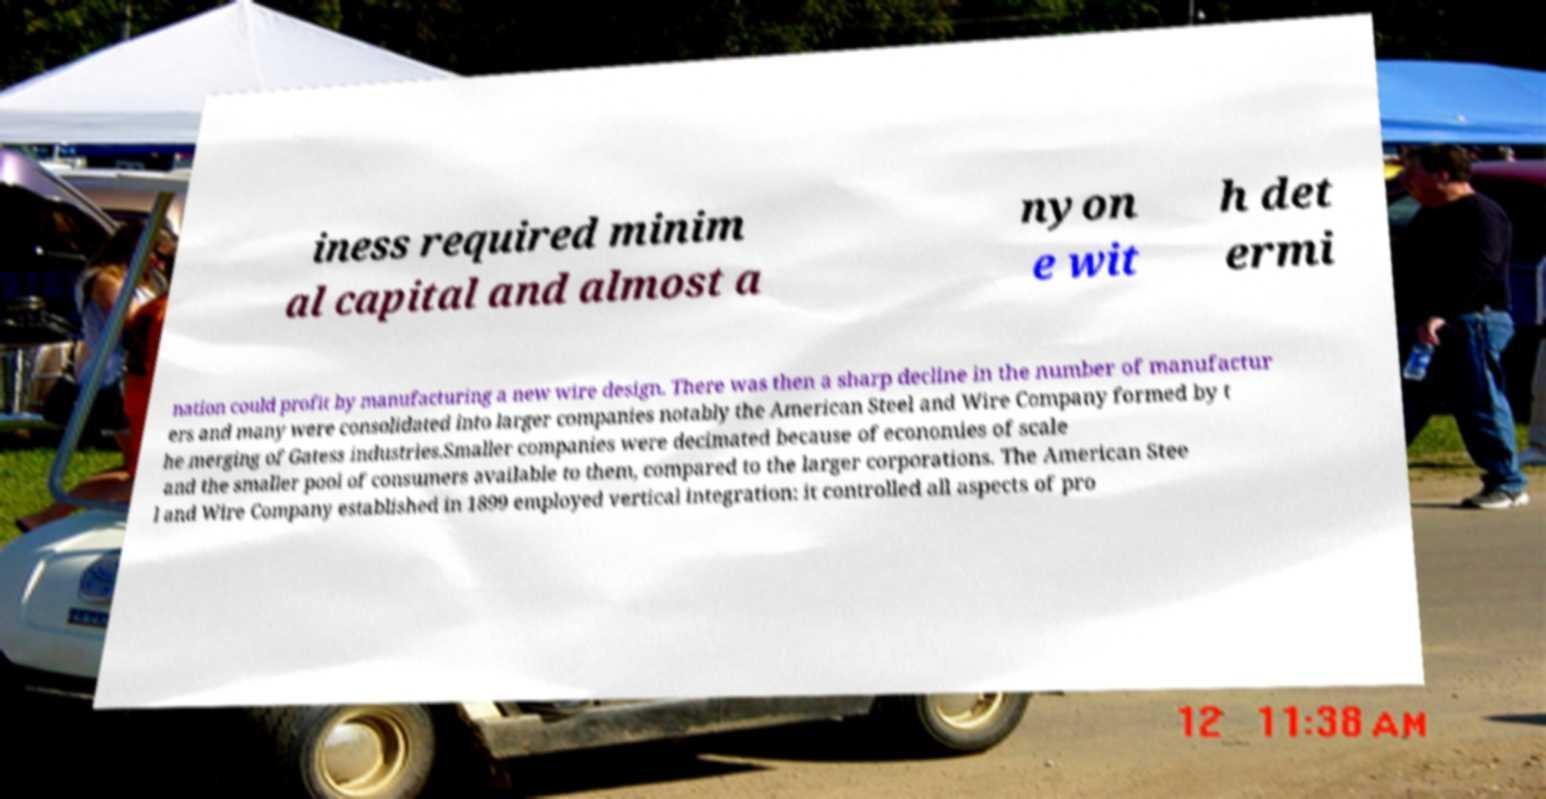There's text embedded in this image that I need extracted. Can you transcribe it verbatim? iness required minim al capital and almost a nyon e wit h det ermi nation could profit by manufacturing a new wire design. There was then a sharp decline in the number of manufactur ers and many were consolidated into larger companies notably the American Steel and Wire Company formed by t he merging of Gatess industries.Smaller companies were decimated because of economies of scale and the smaller pool of consumers available to them, compared to the larger corporations. The American Stee l and Wire Company established in 1899 employed vertical integration: it controlled all aspects of pro 